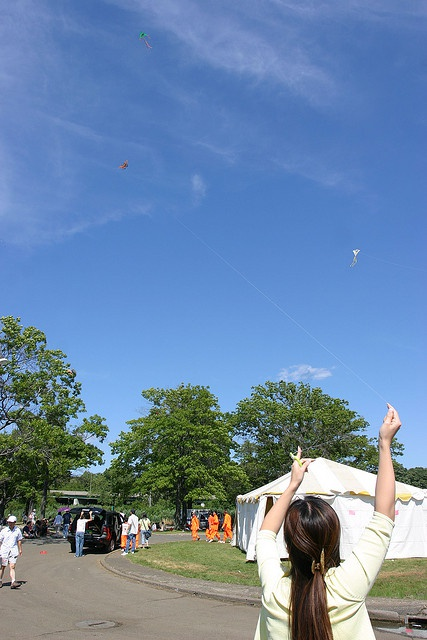Describe the objects in this image and their specific colors. I can see people in gray, ivory, black, tan, and maroon tones, car in gray, black, navy, and maroon tones, people in gray, white, and darkgray tones, people in gray, white, and black tones, and people in gray, white, and darkgray tones in this image. 